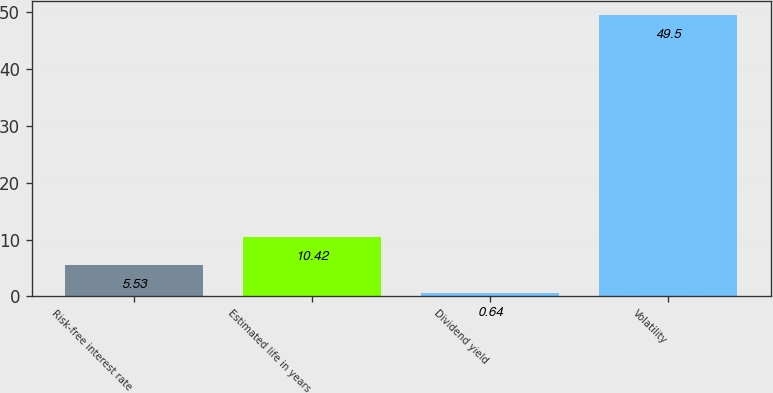Convert chart. <chart><loc_0><loc_0><loc_500><loc_500><bar_chart><fcel>Risk-free interest rate<fcel>Estimated life in years<fcel>Dividend yield<fcel>Volatility<nl><fcel>5.53<fcel>10.42<fcel>0.64<fcel>49.5<nl></chart> 